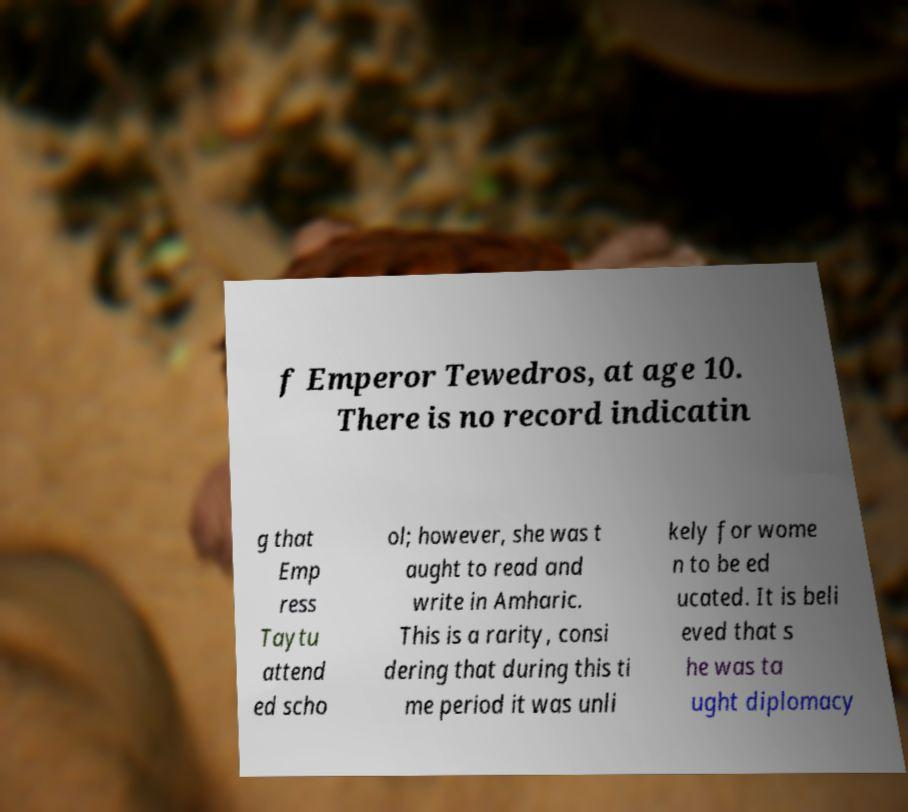There's text embedded in this image that I need extracted. Can you transcribe it verbatim? f Emperor Tewedros, at age 10. There is no record indicatin g that Emp ress Taytu attend ed scho ol; however, she was t aught to read and write in Amharic. This is a rarity, consi dering that during this ti me period it was unli kely for wome n to be ed ucated. It is beli eved that s he was ta ught diplomacy 